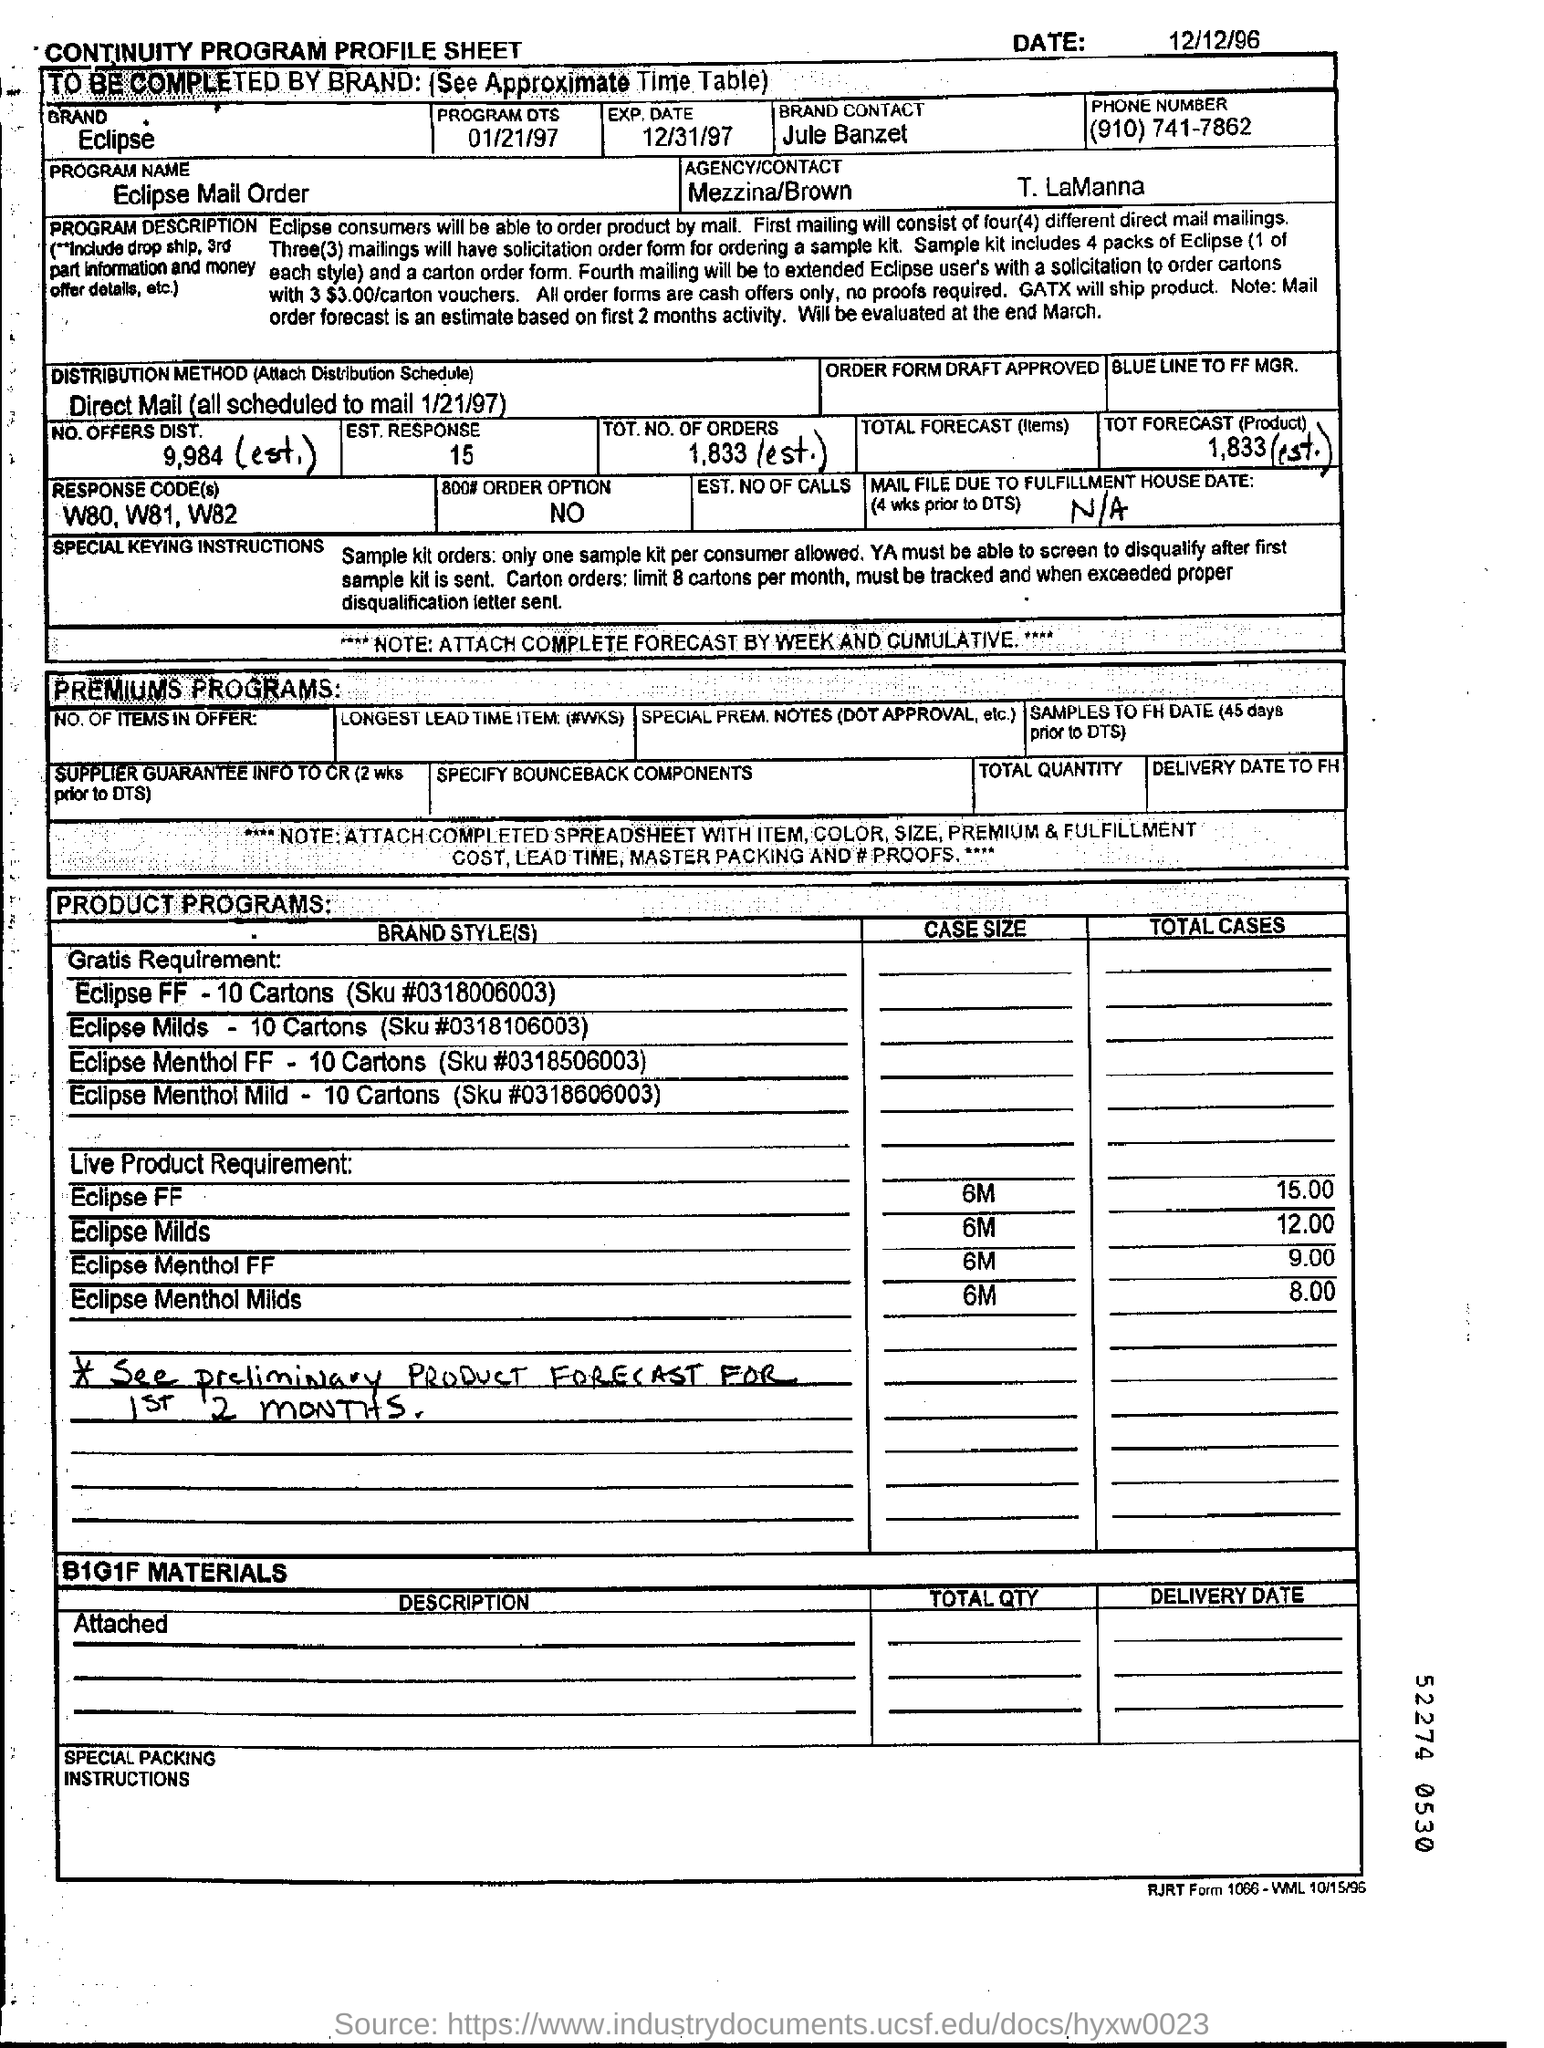What is the DISTRIBUTION METHOD?
Your answer should be compact. Direct Mail (all scheduled to mail 1/21/97). 